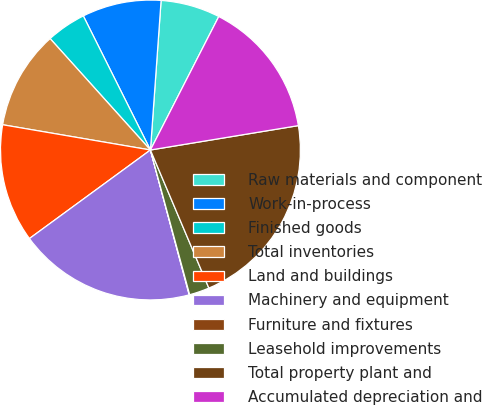Convert chart. <chart><loc_0><loc_0><loc_500><loc_500><pie_chart><fcel>Raw materials and component<fcel>Work-in-process<fcel>Finished goods<fcel>Total inventories<fcel>Land and buildings<fcel>Machinery and equipment<fcel>Furniture and fixtures<fcel>Leasehold improvements<fcel>Total property plant and<fcel>Accumulated depreciation and<nl><fcel>6.4%<fcel>8.52%<fcel>4.28%<fcel>10.64%<fcel>12.75%<fcel>19.11%<fcel>0.05%<fcel>2.16%<fcel>21.23%<fcel>14.87%<nl></chart> 